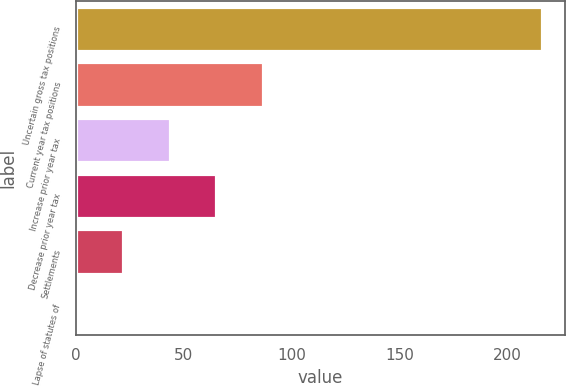Convert chart to OTSL. <chart><loc_0><loc_0><loc_500><loc_500><bar_chart><fcel>Uncertain gross tax positions<fcel>Current year tax positions<fcel>Increase prior year tax<fcel>Decrease prior year tax<fcel>Settlements<fcel>Lapse of statutes of<nl><fcel>216.1<fcel>86.56<fcel>43.38<fcel>64.97<fcel>21.79<fcel>0.2<nl></chart> 